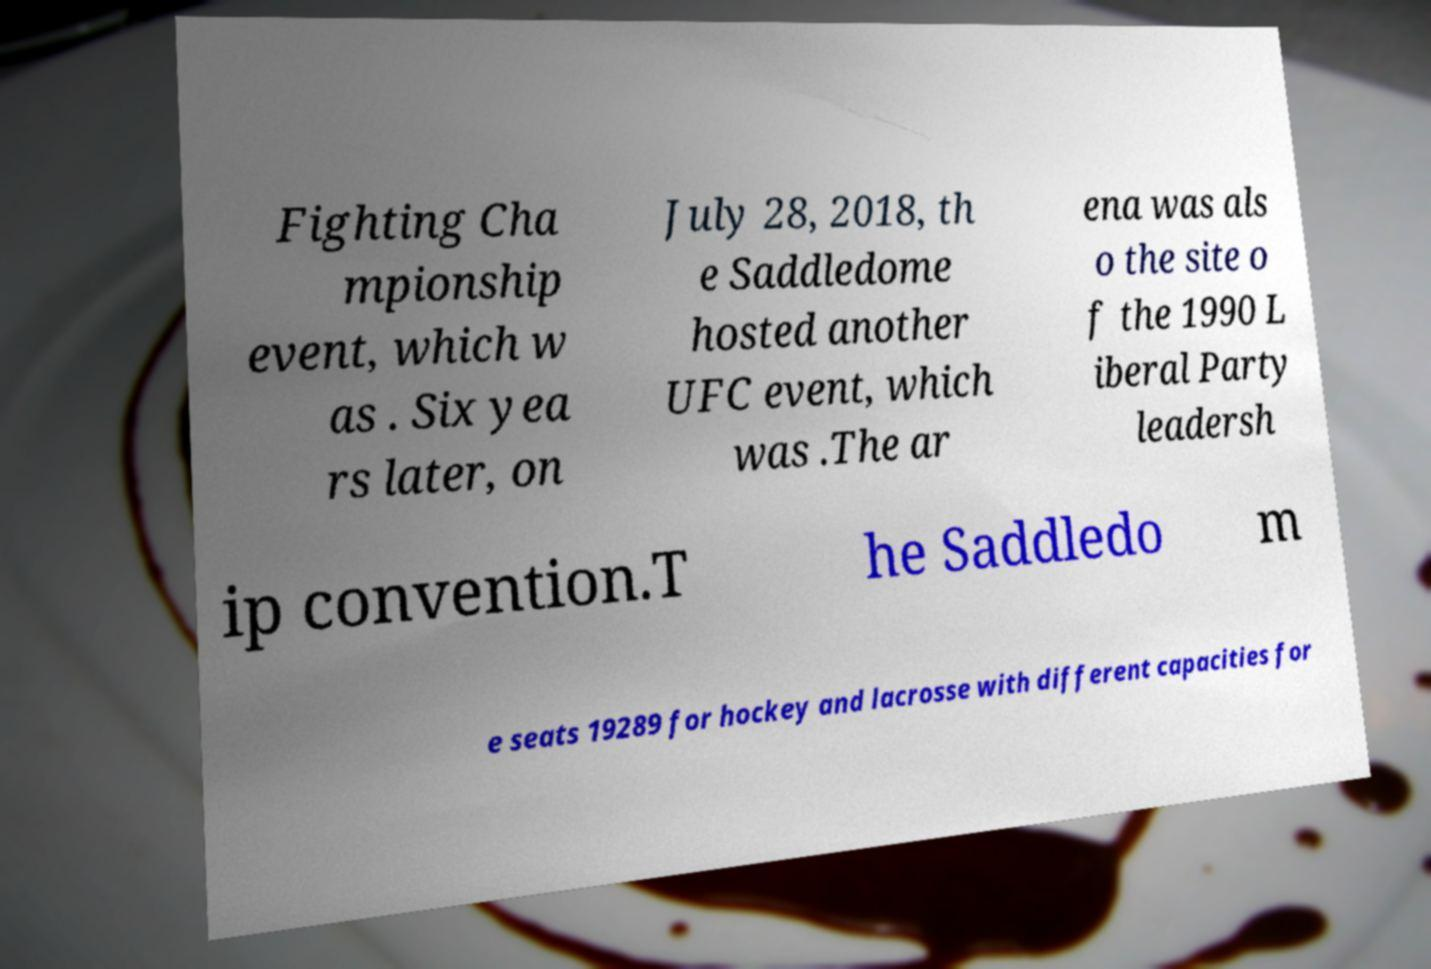Could you assist in decoding the text presented in this image and type it out clearly? Fighting Cha mpionship event, which w as . Six yea rs later, on July 28, 2018, th e Saddledome hosted another UFC event, which was .The ar ena was als o the site o f the 1990 L iberal Party leadersh ip convention.T he Saddledo m e seats 19289 for hockey and lacrosse with different capacities for 